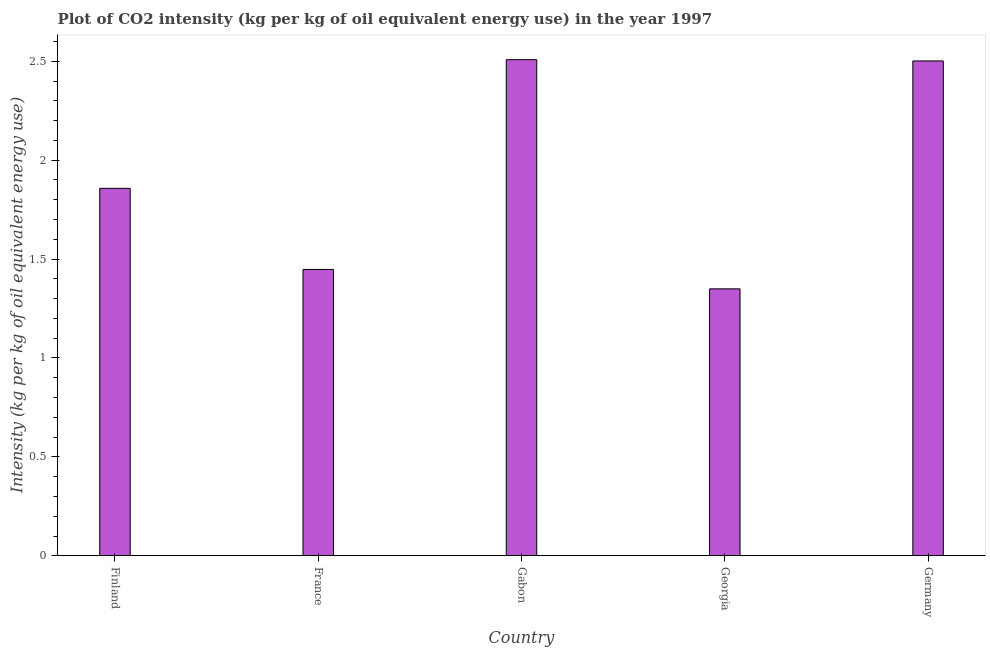Does the graph contain grids?
Your answer should be compact. No. What is the title of the graph?
Your answer should be very brief. Plot of CO2 intensity (kg per kg of oil equivalent energy use) in the year 1997. What is the label or title of the Y-axis?
Give a very brief answer. Intensity (kg per kg of oil equivalent energy use). What is the co2 intensity in Germany?
Provide a short and direct response. 2.5. Across all countries, what is the maximum co2 intensity?
Ensure brevity in your answer.  2.51. Across all countries, what is the minimum co2 intensity?
Provide a succinct answer. 1.35. In which country was the co2 intensity maximum?
Keep it short and to the point. Gabon. In which country was the co2 intensity minimum?
Provide a short and direct response. Georgia. What is the sum of the co2 intensity?
Your answer should be compact. 9.66. What is the difference between the co2 intensity in France and Germany?
Your answer should be very brief. -1.05. What is the average co2 intensity per country?
Your response must be concise. 1.93. What is the median co2 intensity?
Your response must be concise. 1.86. In how many countries, is the co2 intensity greater than 1.4 kg?
Your answer should be very brief. 4. What is the ratio of the co2 intensity in France to that in Gabon?
Your response must be concise. 0.58. Is the co2 intensity in Gabon less than that in Georgia?
Your answer should be very brief. No. Is the difference between the co2 intensity in France and Gabon greater than the difference between any two countries?
Offer a very short reply. No. What is the difference between the highest and the second highest co2 intensity?
Your answer should be very brief. 0.01. Is the sum of the co2 intensity in Finland and Gabon greater than the maximum co2 intensity across all countries?
Your answer should be compact. Yes. What is the difference between the highest and the lowest co2 intensity?
Provide a short and direct response. 1.16. In how many countries, is the co2 intensity greater than the average co2 intensity taken over all countries?
Provide a succinct answer. 2. How many bars are there?
Your answer should be very brief. 5. Are all the bars in the graph horizontal?
Provide a succinct answer. No. What is the difference between two consecutive major ticks on the Y-axis?
Offer a terse response. 0.5. What is the Intensity (kg per kg of oil equivalent energy use) of Finland?
Offer a very short reply. 1.86. What is the Intensity (kg per kg of oil equivalent energy use) of France?
Give a very brief answer. 1.45. What is the Intensity (kg per kg of oil equivalent energy use) in Gabon?
Provide a succinct answer. 2.51. What is the Intensity (kg per kg of oil equivalent energy use) of Georgia?
Offer a terse response. 1.35. What is the Intensity (kg per kg of oil equivalent energy use) in Germany?
Give a very brief answer. 2.5. What is the difference between the Intensity (kg per kg of oil equivalent energy use) in Finland and France?
Ensure brevity in your answer.  0.41. What is the difference between the Intensity (kg per kg of oil equivalent energy use) in Finland and Gabon?
Your answer should be very brief. -0.65. What is the difference between the Intensity (kg per kg of oil equivalent energy use) in Finland and Georgia?
Your response must be concise. 0.51. What is the difference between the Intensity (kg per kg of oil equivalent energy use) in Finland and Germany?
Your answer should be compact. -0.64. What is the difference between the Intensity (kg per kg of oil equivalent energy use) in France and Gabon?
Your response must be concise. -1.06. What is the difference between the Intensity (kg per kg of oil equivalent energy use) in France and Georgia?
Offer a terse response. 0.1. What is the difference between the Intensity (kg per kg of oil equivalent energy use) in France and Germany?
Provide a short and direct response. -1.05. What is the difference between the Intensity (kg per kg of oil equivalent energy use) in Gabon and Georgia?
Offer a terse response. 1.16. What is the difference between the Intensity (kg per kg of oil equivalent energy use) in Gabon and Germany?
Offer a terse response. 0.01. What is the difference between the Intensity (kg per kg of oil equivalent energy use) in Georgia and Germany?
Provide a short and direct response. -1.15. What is the ratio of the Intensity (kg per kg of oil equivalent energy use) in Finland to that in France?
Offer a very short reply. 1.28. What is the ratio of the Intensity (kg per kg of oil equivalent energy use) in Finland to that in Gabon?
Make the answer very short. 0.74. What is the ratio of the Intensity (kg per kg of oil equivalent energy use) in Finland to that in Georgia?
Provide a short and direct response. 1.38. What is the ratio of the Intensity (kg per kg of oil equivalent energy use) in Finland to that in Germany?
Give a very brief answer. 0.74. What is the ratio of the Intensity (kg per kg of oil equivalent energy use) in France to that in Gabon?
Your answer should be very brief. 0.58. What is the ratio of the Intensity (kg per kg of oil equivalent energy use) in France to that in Georgia?
Offer a terse response. 1.07. What is the ratio of the Intensity (kg per kg of oil equivalent energy use) in France to that in Germany?
Ensure brevity in your answer.  0.58. What is the ratio of the Intensity (kg per kg of oil equivalent energy use) in Gabon to that in Georgia?
Your answer should be very brief. 1.86. What is the ratio of the Intensity (kg per kg of oil equivalent energy use) in Georgia to that in Germany?
Your answer should be compact. 0.54. 